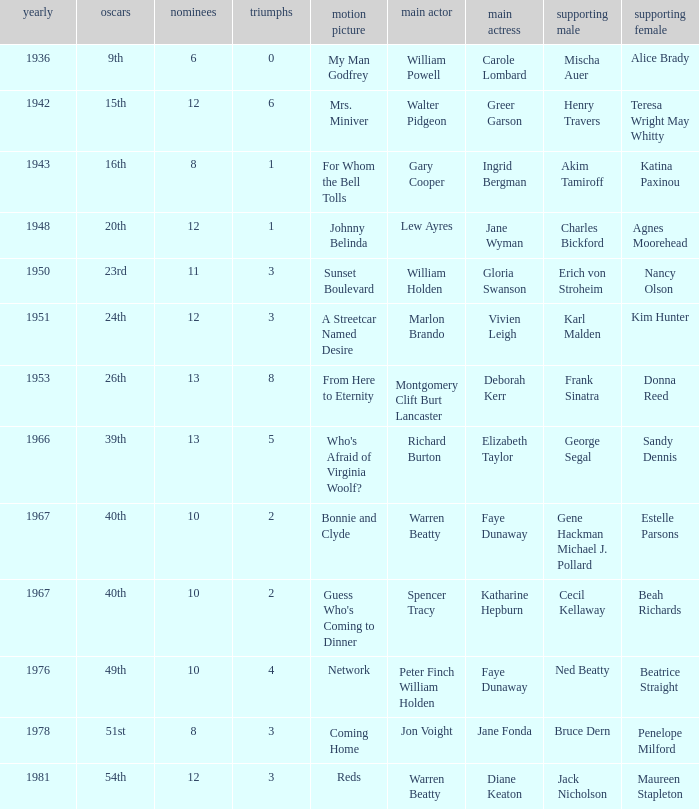Who was the supporting actress in 1943? Katina Paxinou. 